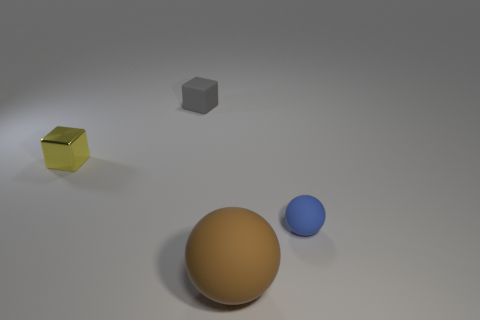Subtract all yellow blocks. How many blocks are left? 1 Add 1 blue rubber balls. How many objects exist? 5 Subtract 1 spheres. How many spheres are left? 1 Subtract all red cubes. How many brown spheres are left? 1 Subtract all brown metallic balls. Subtract all brown matte objects. How many objects are left? 3 Add 4 small rubber cubes. How many small rubber cubes are left? 5 Add 3 large blue objects. How many large blue objects exist? 3 Subtract 0 green blocks. How many objects are left? 4 Subtract all red cubes. Subtract all cyan spheres. How many cubes are left? 2 